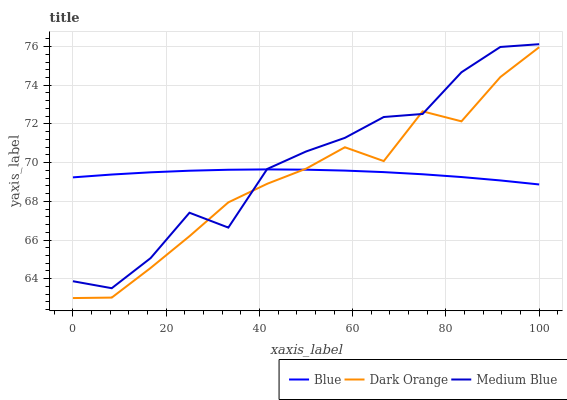Does Dark Orange have the minimum area under the curve?
Answer yes or no. Yes. Does Medium Blue have the maximum area under the curve?
Answer yes or no. Yes. Does Medium Blue have the minimum area under the curve?
Answer yes or no. No. Does Dark Orange have the maximum area under the curve?
Answer yes or no. No. Is Blue the smoothest?
Answer yes or no. Yes. Is Medium Blue the roughest?
Answer yes or no. Yes. Is Dark Orange the smoothest?
Answer yes or no. No. Is Dark Orange the roughest?
Answer yes or no. No. Does Dark Orange have the lowest value?
Answer yes or no. Yes. Does Medium Blue have the lowest value?
Answer yes or no. No. Does Medium Blue have the highest value?
Answer yes or no. Yes. Does Dark Orange have the highest value?
Answer yes or no. No. Does Medium Blue intersect Dark Orange?
Answer yes or no. Yes. Is Medium Blue less than Dark Orange?
Answer yes or no. No. Is Medium Blue greater than Dark Orange?
Answer yes or no. No. 